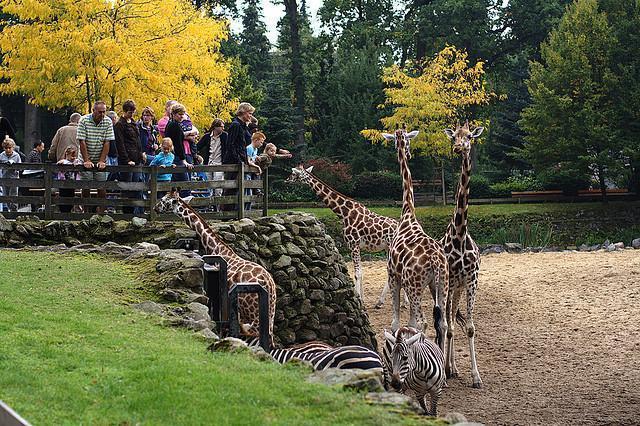How many giraffes are standing?
Give a very brief answer. 4. How many people can be seen?
Give a very brief answer. 2. How many giraffes can be seen?
Give a very brief answer. 4. How many zebras are there?
Give a very brief answer. 2. 